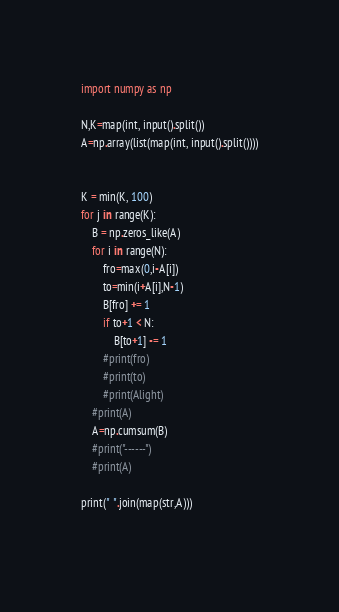<code> <loc_0><loc_0><loc_500><loc_500><_Python_>import numpy as np

N,K=map(int, input().split())
A=np.array(list(map(int, input().split())))


K = min(K, 100)
for j in range(K):
    B = np.zeros_like(A)
    for i in range(N):
        fro=max(0,i-A[i])
        to=min(i+A[i],N-1)
        B[fro] += 1
        if to+1 < N:
            B[to+1] -= 1
        #print(fro)
        #print(to)
        #print(Alight)
    #print(A)
    A=np.cumsum(B)
    #print("------")
    #print(A)

print(" ".join(map(str,A)))
    




</code> 